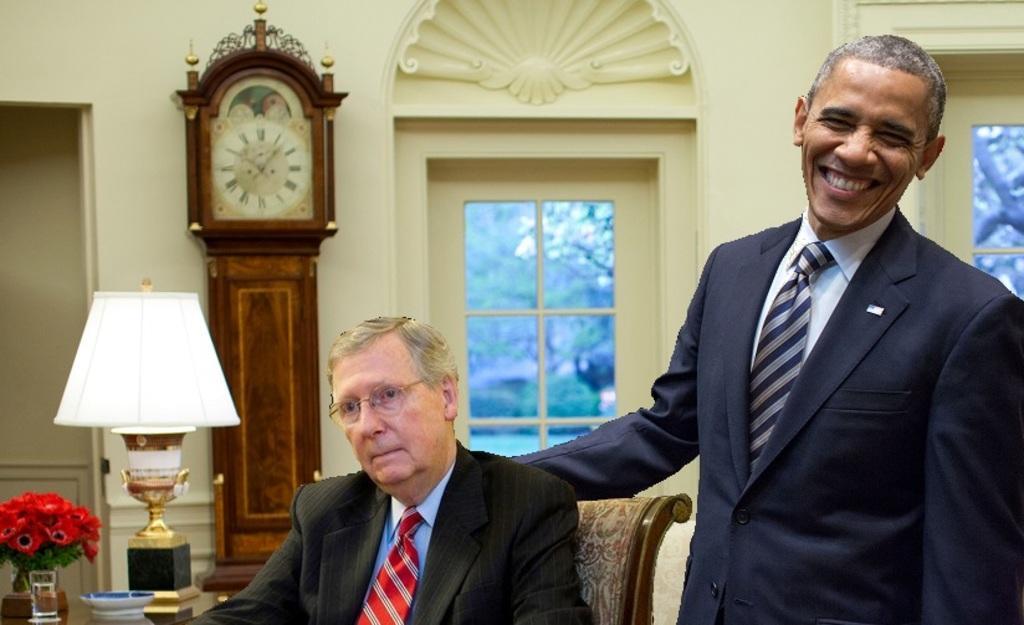How would you summarize this image in a sentence or two? In this image we can see a person standing on the right side of the image is smiling. This person is sitting on the chair. There are glass, plate, flower vase and lamp on the table. In the background we can see a clock. 